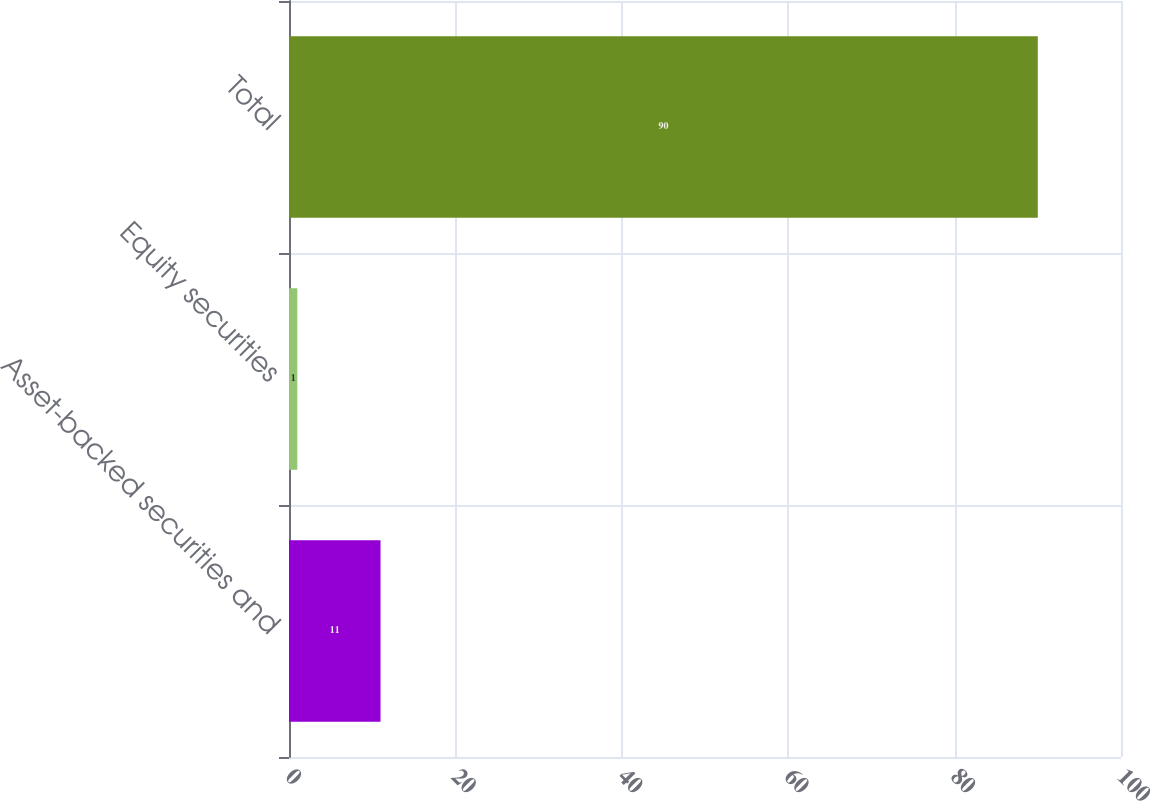<chart> <loc_0><loc_0><loc_500><loc_500><bar_chart><fcel>Asset-backed securities and<fcel>Equity securities<fcel>Total<nl><fcel>11<fcel>1<fcel>90<nl></chart> 